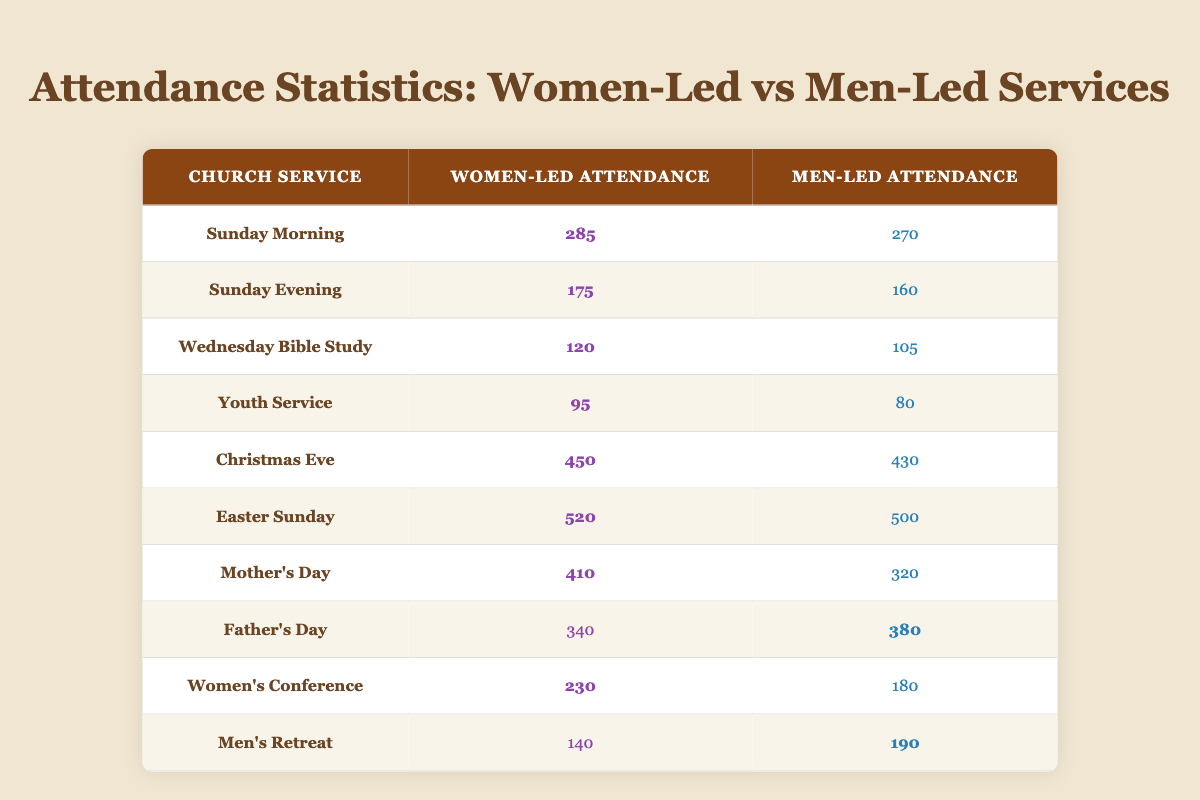What is the attendance for the Women's Conference? The attendance for the Women's Conference is directly listed in the table under the "Women-Led Attendance" column. Looking at the row for "Women's Conference," I see a value of 230.
Answer: 230 What is the difference in attendance between Mother's Day and Father's Day services? To find the difference, first check the attendance for Mother's Day, which is 410 for women and 320 for men. For Father's Day, the attendance is 340 for women and 380 for men. Subtract the Father's Day attendance (380) from Mother's Day (320) to calculate the difference. The results show that Mother's Day had 410 - 320 = 90 more attendees.
Answer: 90 Did women-led services have higher attendance than men-led services for Easter Sunday? Looking at Easter Sunday, the attendance for women-led services is 520 while the attendance for men-led services is 500. Since 520 is greater than 500, it confirms that women-led services had higher attendance.
Answer: Yes What is the total attendance for all women-led services listed? To find the total attendance for all women-led services, I will sum up the values from the "Women-Led Attendance" column: 285 + 175 + 120 + 95 + 450 + 520 + 410 + 340 + 230 + 140 = 2325. Therefore, the total attendance for all women-led services is 2325.
Answer: 2325 Which service had the highest attendance, and what was that number? By examining the table, I notice that Easter Sunday has the highest attendance listed for women-led services at 520, which is the maximum value in the "Women-Led Attendance" column.
Answer: Easter Sunday, 520 What percentage of attendees for the Christmas Eve service were women-led? For Christmas Eve, women-led attendance is 450 and men-led is 430, making the total attendance 450 + 430 = 880. To find the percentage of attendance that was women-led, I use the formula: (450 / 880) * 100, which results in approximately 51.14%.
Answer: 51.14% Was the attendance for men-led services greater than 300 during Mother's Day? The attendance for men-led services during Mother's Day is 320 as noted in the table. Since 320 is greater than 300, this statement is true.
Answer: Yes How many more attendees were at the Sunday Morning service compared to the Sunday Evening service or vice versa? The Sunday Morning service had a women-led attendance of 285 and a men-led attendance of 270. The Sunday Evening service had a women-led attendance of 175 and a men-led attendance of 160. I will find the difference in attendance between Sunday Morning (285) and Sunday Evening (175), which is 285 - 175 = 110. I will also find the difference in men-led services: 270 - 160 = 110. In both cases, the numbers are equal at 110.
Answer: 110 